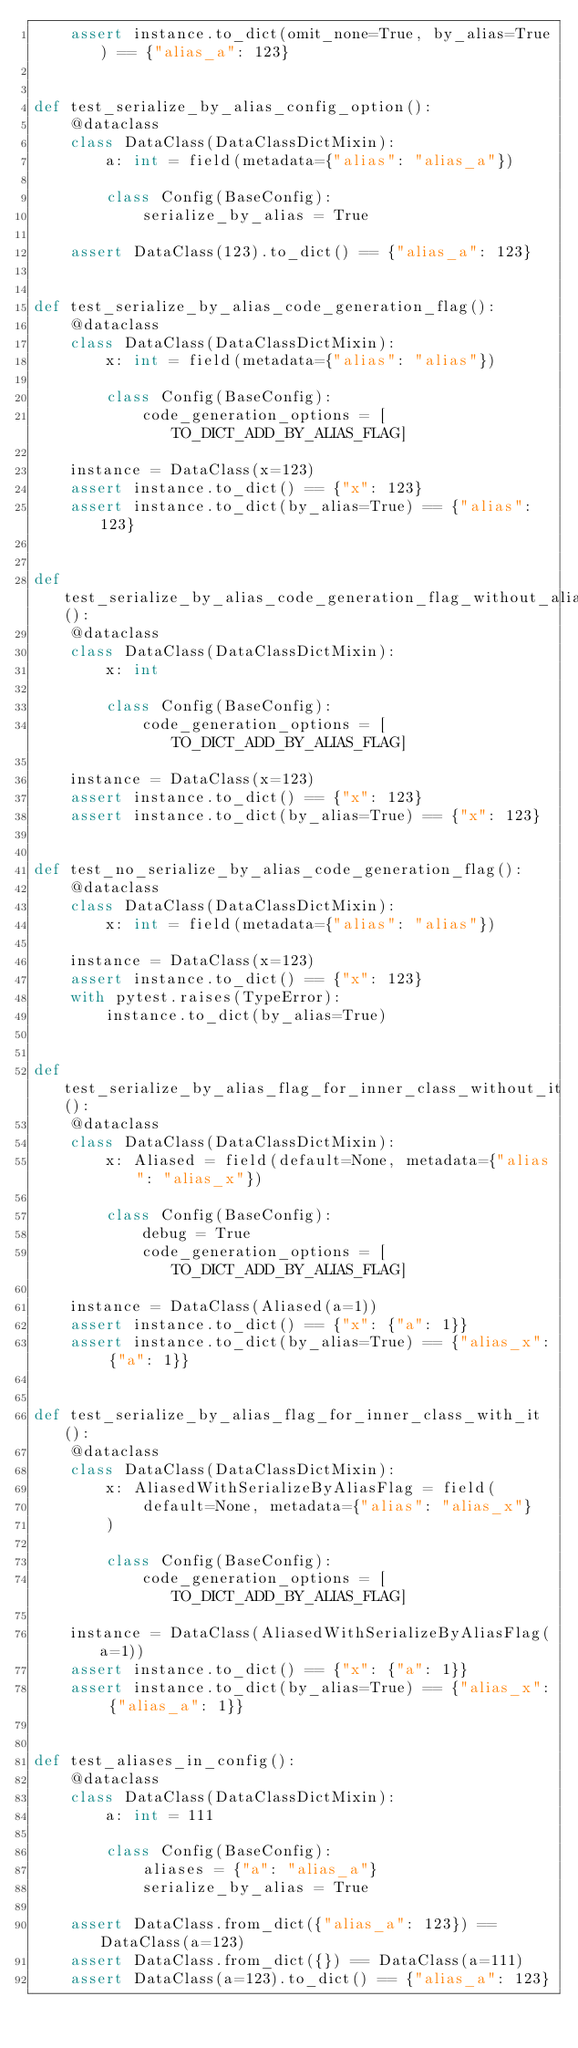Convert code to text. <code><loc_0><loc_0><loc_500><loc_500><_Python_>    assert instance.to_dict(omit_none=True, by_alias=True) == {"alias_a": 123}


def test_serialize_by_alias_config_option():
    @dataclass
    class DataClass(DataClassDictMixin):
        a: int = field(metadata={"alias": "alias_a"})

        class Config(BaseConfig):
            serialize_by_alias = True

    assert DataClass(123).to_dict() == {"alias_a": 123}


def test_serialize_by_alias_code_generation_flag():
    @dataclass
    class DataClass(DataClassDictMixin):
        x: int = field(metadata={"alias": "alias"})

        class Config(BaseConfig):
            code_generation_options = [TO_DICT_ADD_BY_ALIAS_FLAG]

    instance = DataClass(x=123)
    assert instance.to_dict() == {"x": 123}
    assert instance.to_dict(by_alias=True) == {"alias": 123}


def test_serialize_by_alias_code_generation_flag_without_alias():
    @dataclass
    class DataClass(DataClassDictMixin):
        x: int

        class Config(BaseConfig):
            code_generation_options = [TO_DICT_ADD_BY_ALIAS_FLAG]

    instance = DataClass(x=123)
    assert instance.to_dict() == {"x": 123}
    assert instance.to_dict(by_alias=True) == {"x": 123}


def test_no_serialize_by_alias_code_generation_flag():
    @dataclass
    class DataClass(DataClassDictMixin):
        x: int = field(metadata={"alias": "alias"})

    instance = DataClass(x=123)
    assert instance.to_dict() == {"x": 123}
    with pytest.raises(TypeError):
        instance.to_dict(by_alias=True)


def test_serialize_by_alias_flag_for_inner_class_without_it():
    @dataclass
    class DataClass(DataClassDictMixin):
        x: Aliased = field(default=None, metadata={"alias": "alias_x"})

        class Config(BaseConfig):
            debug = True
            code_generation_options = [TO_DICT_ADD_BY_ALIAS_FLAG]

    instance = DataClass(Aliased(a=1))
    assert instance.to_dict() == {"x": {"a": 1}}
    assert instance.to_dict(by_alias=True) == {"alias_x": {"a": 1}}


def test_serialize_by_alias_flag_for_inner_class_with_it():
    @dataclass
    class DataClass(DataClassDictMixin):
        x: AliasedWithSerializeByAliasFlag = field(
            default=None, metadata={"alias": "alias_x"}
        )

        class Config(BaseConfig):
            code_generation_options = [TO_DICT_ADD_BY_ALIAS_FLAG]

    instance = DataClass(AliasedWithSerializeByAliasFlag(a=1))
    assert instance.to_dict() == {"x": {"a": 1}}
    assert instance.to_dict(by_alias=True) == {"alias_x": {"alias_a": 1}}


def test_aliases_in_config():
    @dataclass
    class DataClass(DataClassDictMixin):
        a: int = 111

        class Config(BaseConfig):
            aliases = {"a": "alias_a"}
            serialize_by_alias = True

    assert DataClass.from_dict({"alias_a": 123}) == DataClass(a=123)
    assert DataClass.from_dict({}) == DataClass(a=111)
    assert DataClass(a=123).to_dict() == {"alias_a": 123}

</code> 